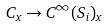Convert formula to latex. <formula><loc_0><loc_0><loc_500><loc_500>C _ { x } \rightarrow C ^ { \infty } ( S _ { i } ) _ { x }</formula> 